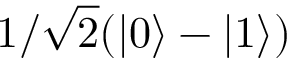<formula> <loc_0><loc_0><loc_500><loc_500>1 / \sqrt { 2 } ( | 0 \rangle - | 1 \rangle )</formula> 